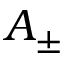<formula> <loc_0><loc_0><loc_500><loc_500>A _ { \pm }</formula> 